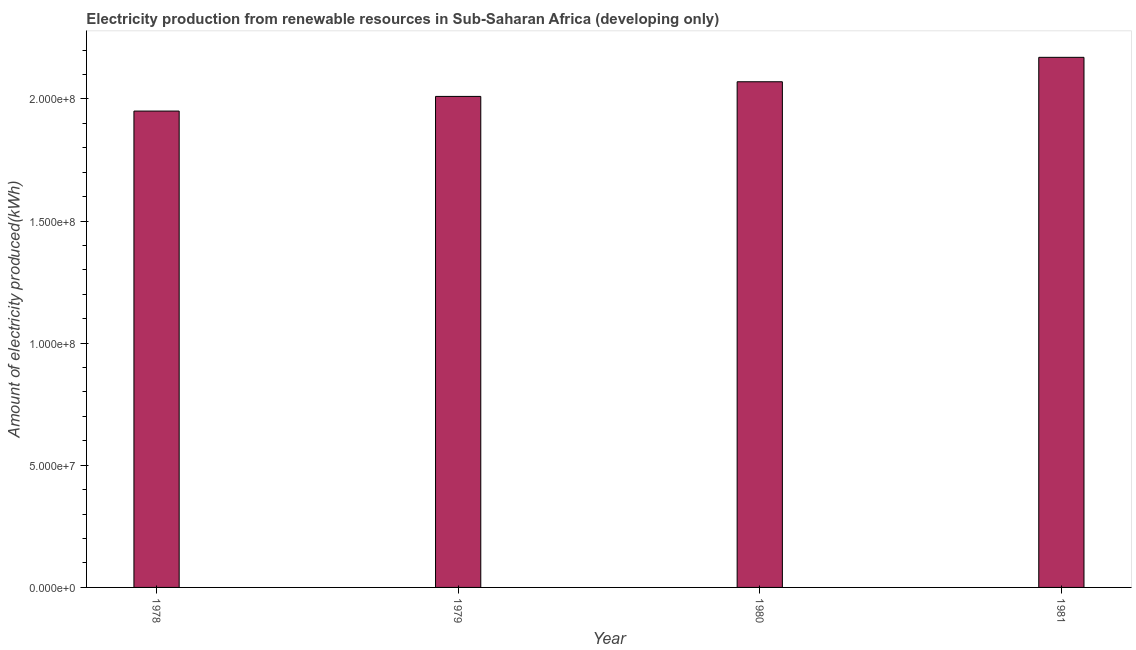Does the graph contain any zero values?
Offer a terse response. No. Does the graph contain grids?
Offer a terse response. No. What is the title of the graph?
Provide a short and direct response. Electricity production from renewable resources in Sub-Saharan Africa (developing only). What is the label or title of the Y-axis?
Ensure brevity in your answer.  Amount of electricity produced(kWh). What is the amount of electricity produced in 1979?
Provide a succinct answer. 2.01e+08. Across all years, what is the maximum amount of electricity produced?
Your answer should be compact. 2.17e+08. Across all years, what is the minimum amount of electricity produced?
Offer a very short reply. 1.95e+08. In which year was the amount of electricity produced minimum?
Keep it short and to the point. 1978. What is the sum of the amount of electricity produced?
Make the answer very short. 8.20e+08. What is the difference between the amount of electricity produced in 1979 and 1981?
Your answer should be compact. -1.60e+07. What is the average amount of electricity produced per year?
Make the answer very short. 2.05e+08. What is the median amount of electricity produced?
Keep it short and to the point. 2.04e+08. In how many years, is the amount of electricity produced greater than 20000000 kWh?
Your answer should be very brief. 4. What is the ratio of the amount of electricity produced in 1978 to that in 1979?
Your response must be concise. 0.97. Is the difference between the amount of electricity produced in 1978 and 1979 greater than the difference between any two years?
Ensure brevity in your answer.  No. What is the difference between the highest and the lowest amount of electricity produced?
Your answer should be very brief. 2.20e+07. In how many years, is the amount of electricity produced greater than the average amount of electricity produced taken over all years?
Provide a short and direct response. 2. Are all the bars in the graph horizontal?
Provide a succinct answer. No. What is the Amount of electricity produced(kWh) of 1978?
Make the answer very short. 1.95e+08. What is the Amount of electricity produced(kWh) of 1979?
Your answer should be compact. 2.01e+08. What is the Amount of electricity produced(kWh) in 1980?
Your answer should be very brief. 2.07e+08. What is the Amount of electricity produced(kWh) in 1981?
Your response must be concise. 2.17e+08. What is the difference between the Amount of electricity produced(kWh) in 1978 and 1979?
Give a very brief answer. -6.00e+06. What is the difference between the Amount of electricity produced(kWh) in 1978 and 1980?
Offer a very short reply. -1.20e+07. What is the difference between the Amount of electricity produced(kWh) in 1978 and 1981?
Keep it short and to the point. -2.20e+07. What is the difference between the Amount of electricity produced(kWh) in 1979 and 1980?
Your response must be concise. -6.00e+06. What is the difference between the Amount of electricity produced(kWh) in 1979 and 1981?
Keep it short and to the point. -1.60e+07. What is the difference between the Amount of electricity produced(kWh) in 1980 and 1981?
Provide a short and direct response. -1.00e+07. What is the ratio of the Amount of electricity produced(kWh) in 1978 to that in 1979?
Keep it short and to the point. 0.97. What is the ratio of the Amount of electricity produced(kWh) in 1978 to that in 1980?
Your answer should be very brief. 0.94. What is the ratio of the Amount of electricity produced(kWh) in 1978 to that in 1981?
Your answer should be compact. 0.9. What is the ratio of the Amount of electricity produced(kWh) in 1979 to that in 1980?
Provide a short and direct response. 0.97. What is the ratio of the Amount of electricity produced(kWh) in 1979 to that in 1981?
Offer a very short reply. 0.93. What is the ratio of the Amount of electricity produced(kWh) in 1980 to that in 1981?
Give a very brief answer. 0.95. 